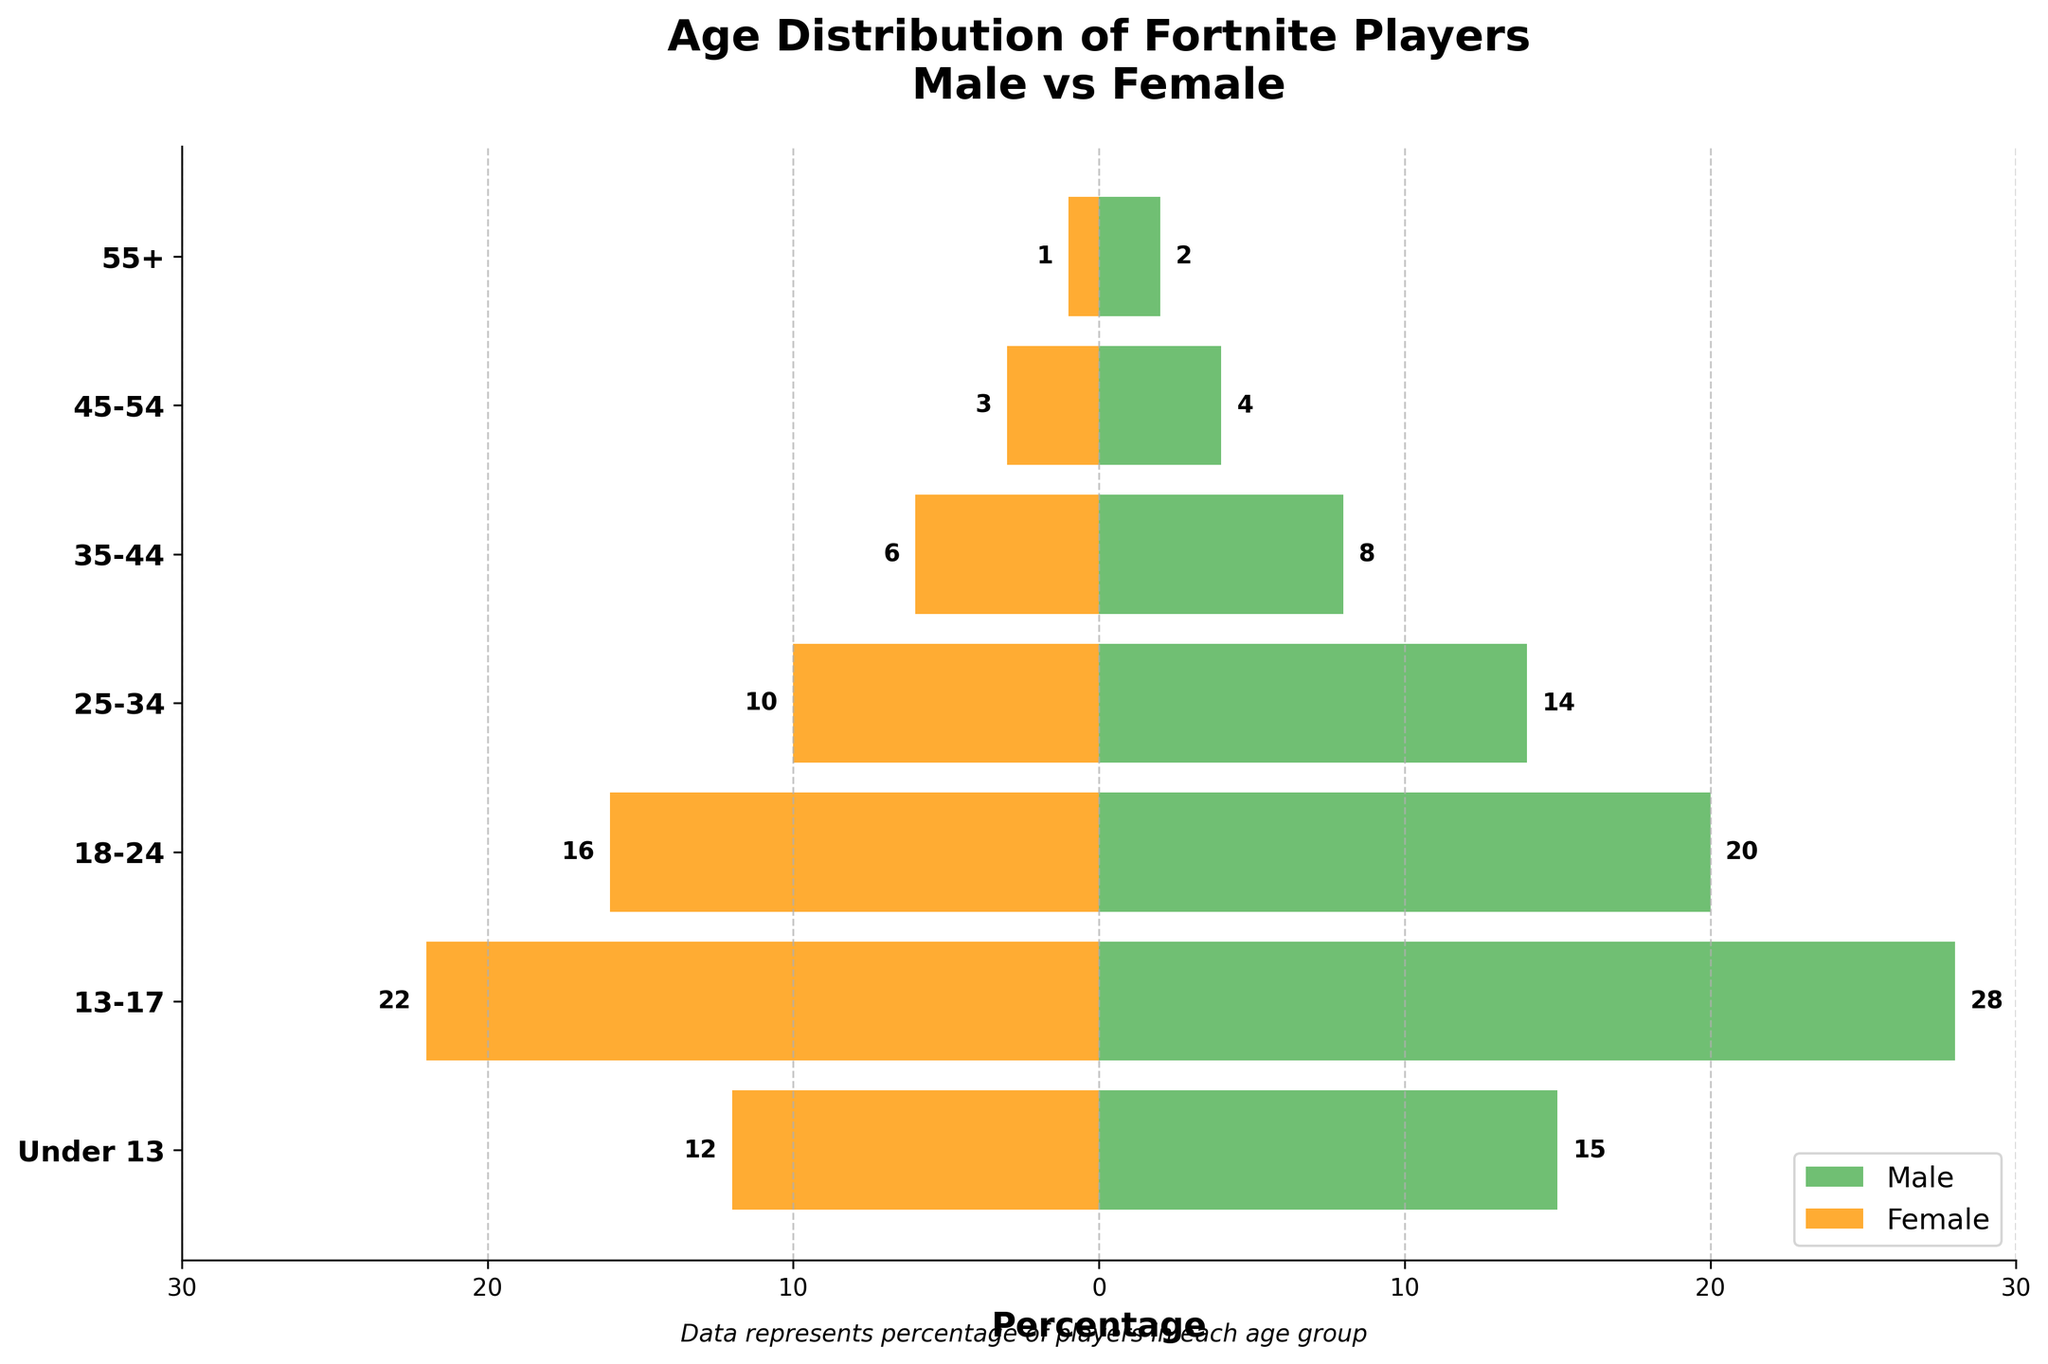What is the title of the figure? The title is displayed prominently at the top of the figure.
Answer: Age Distribution of Fortnite Players: Male vs Female Which age group has the highest percentage of male Fortnite players? By observing the lengths of the green male bars, the age group with the longest bar is identified as having the highest percentage of male players.
Answer: 13-17 How many age groups are represented in the figure? Count the number of unique labels along the y-axis, each representing a different age group.
Answer: 7 What is the percentage difference between male and female players in the 25-34 age group? For the 25-34 age group, the male bar indicates 14%, and the female bar indicates 10%. The percentage difference is calculated as 14 - 10.
Answer: 4% Which age group has a higher percentage of female players compared to male players? Compare the lengths of the orange female bars with the green male bars across all age groups to find where the female percentage is higher.
Answer: None What is the combined percentage of male players in the 35-44 and 45-54 age groups? Add the percentages for the male bars in the 35-44 and 45-54 age groups: 8 for 35-44 and 4 for 45-54. The combined percentage is 8 + 4.
Answer: 12% How do the percentages of male and female players compare in the Under 13 age group? Compare the lengths of the green and orange bars for the Under 13 age group, which show the percentages for both male and female respectively.
Answer: Male: 15%, Female: 12% Which age group has the smallest percentage of Fortnite players, regardless of gender? Identify the age group with the shortest total bar lengths (both green and orange combined).
Answer: 55+ What overall trend can be observed in the gender distribution across all age groups? Observe the general pattern of bar lengths from top to bottom to notice any increasing or decreasing trends in gender distribution.
Answer: Most age groups have more male players than female players, and the percentage of players decreases with age for both genders Calculate the average percentage of male Fortnite players across all age groups. Add the percentages of male players in each age group: 15 + 28 + 20 + 14 + 8 + 4 + 2. Divide the sum by the number of age groups (7).
Answer: 13.0% 